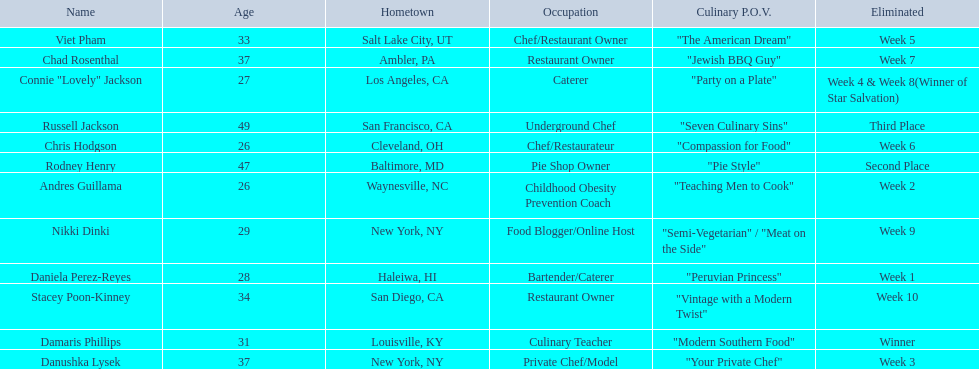Excluding the winner, and second and third place winners, who were the contestants eliminated? Stacey Poon-Kinney, Nikki Dinki, Chad Rosenthal, Chris Hodgson, Viet Pham, Connie "Lovely" Jackson, Danushka Lysek, Andres Guillama, Daniela Perez-Reyes. Of these contestants, who were the last five eliminated before the winner, second, and third place winners were announce? Stacey Poon-Kinney, Nikki Dinki, Chad Rosenthal, Chris Hodgson, Viet Pham. Of these five contestants, was nikki dinki or viet pham eliminated first? Viet Pham. 